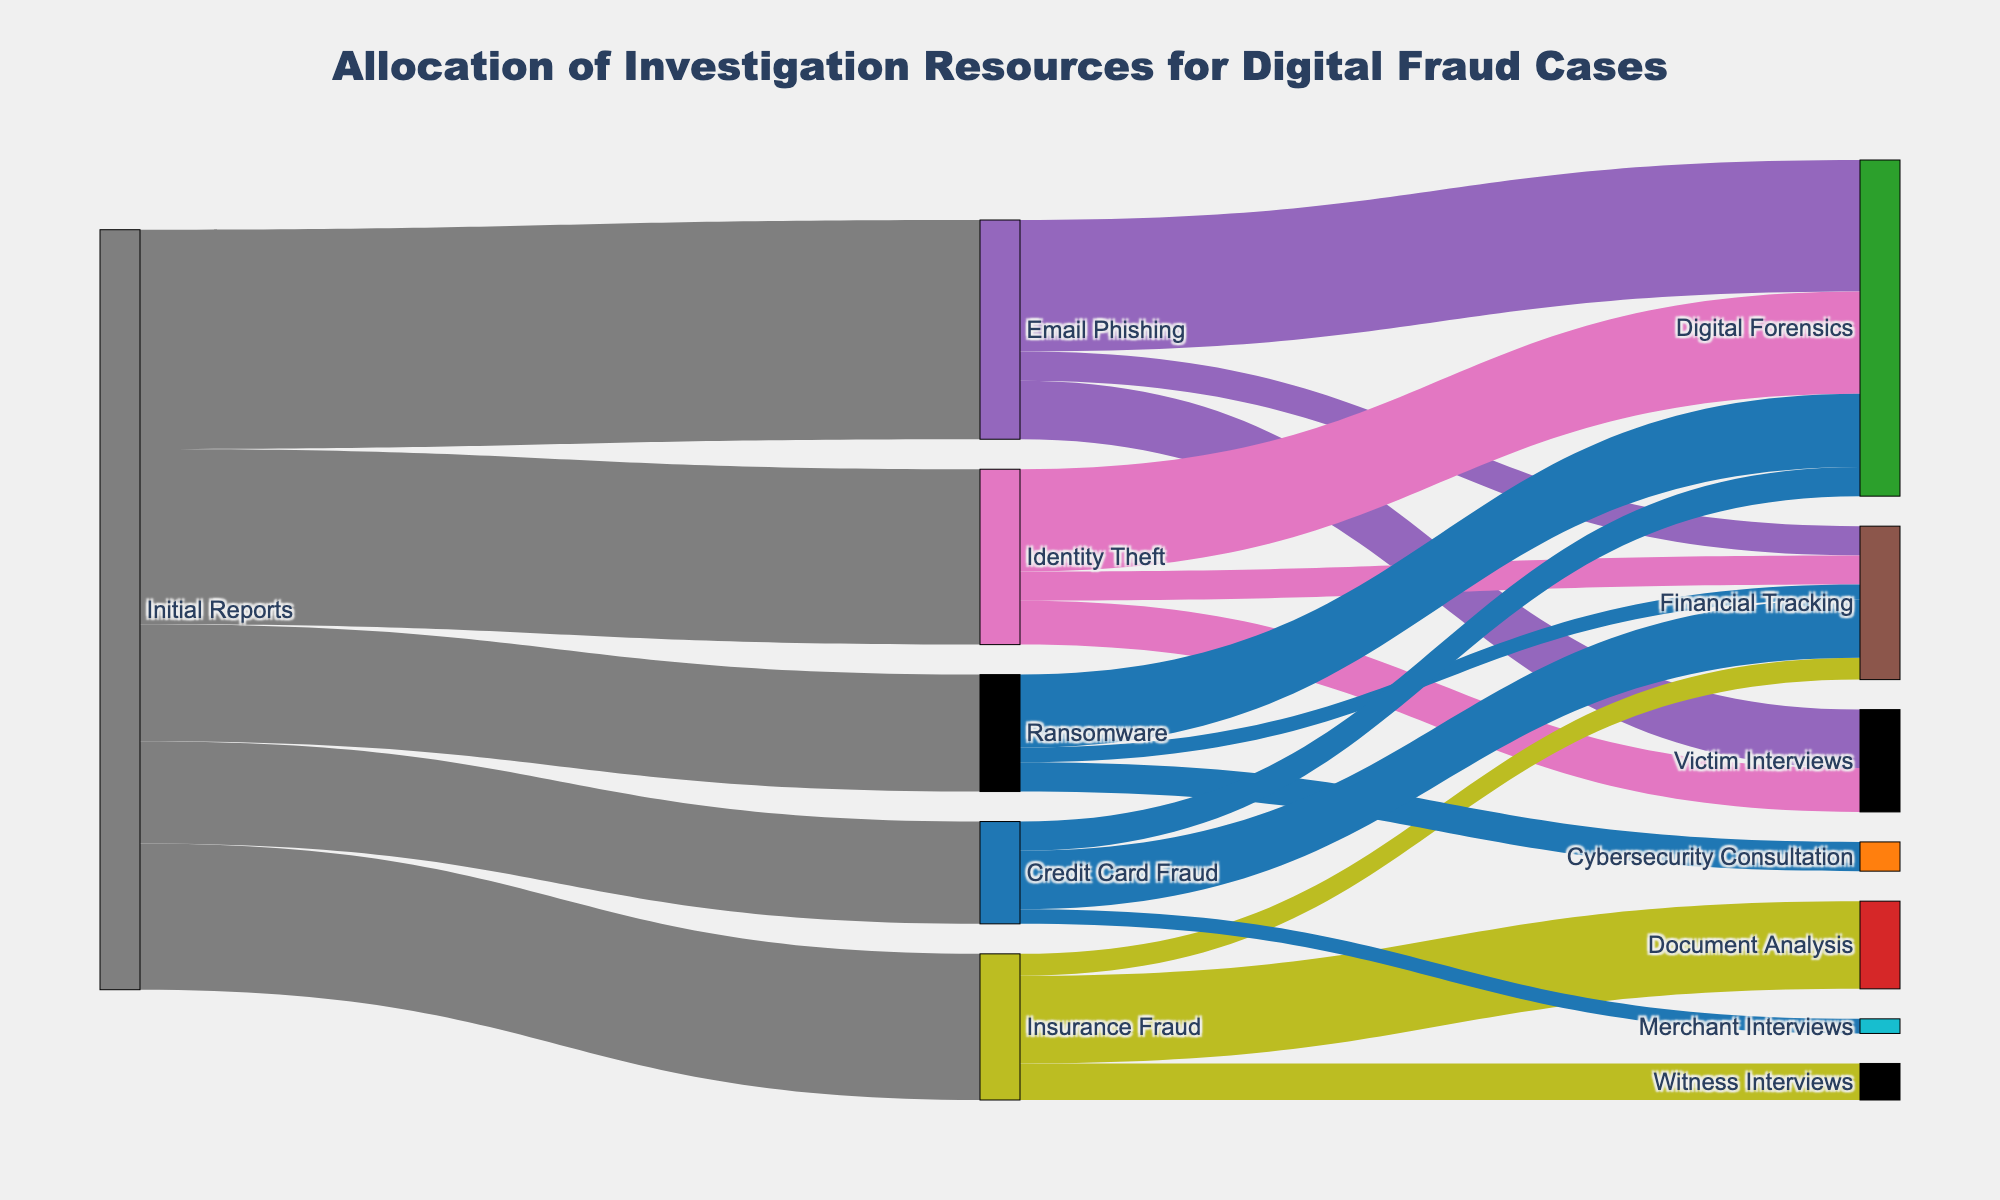What is the title of the Sankey diagram? The title is usually found at the top of the diagram. The title for this Sankey diagram is "Allocation of Investigation Resources for Digital Fraud Cases."
Answer: Allocation of Investigation Resources for Digital Fraud Cases How many different types of fraud cases are reported in the initial reports? To determine this, look at the sources under "Initial Reports." They are Email Phishing, Identity Theft, Insurance Fraud, Ransomware, and Credit Card Fraud. Counting these gives us five.
Answer: Five Which fraud type has the highest number of initial reports? Based on the diagram, check the values associated with each type of fraud stemming from "Initial Reports." The highest value is 150 for Email Phishing.
Answer: Email Phishing How many investigation resources are allocated to Digital Forensics from all fraud types combined? Add the values pointing to Digital Forensics from each fraud type: Email Phishing (90) + Identity Theft (70) + Ransomware (50) + Credit Card Fraud (20). The total is 90 + 70 + 50 + 20 = 230.
Answer: 230 How does the allocation of resources compare between Email Phishing and Insurance Fraud? Sum the resources for each fraud type:
Email Phishing: Digital Forensics (90) + Victim Interviews (40) + Financial Tracking (20) = 150
Insurance Fraud: Document Analysis (60) + Witness Interviews (25) + Financial Tracking (15) = 100
Email Phishing has more resources allocated (150 vs. 100).
Answer: Email Phishing has more resources allocated Which investigation resource is linked to the most types of fraud cases? Check which resource appears as a target for the most different fraud cases:
- Digital Forensics (4: Email Phishing, Identity Theft, Ransomware, Credit Card Fraud)
- Financial Tracking (4: Email Phishing, Identity Theft, Insurance Fraud, Ransomware)
Digital Forensics is linked to the most types of fraud cases.
Answer: Digital Forensics What is the total number of investigation resources allocated to Victim Interviews? Add the values pointing to Victim Interviews from each fraud type: Email Phishing (40) + Identity Theft (30). The total is 40 + 30 = 70.
Answer: 70 Which fraud type has the least amount of initial reports? Compare the initial report values for each fraud type: Email Phishing (150), Identity Theft (120), Insurance Fraud (100), Ransomware (80), Credit Card Fraud (70). Credit Card Fraud has the least amount of initial reports at 70.
Answer: Credit Card Fraud How many resources are allocated to Financial Tracking across all fraud cases? Add the values directed towards Financial Tracking from all sources: Email Phishing (20) + Identity Theft (20) + Insurance Fraud (15) + Ransomware (10) + Credit Card Fraud (40). The total is 20 + 20 + 15 + 10 + 40 = 105.
Answer: 105 What percentage of resources for Ransomware is allocated to Cybersecurity Consultation? Calculate the percentage of Cybersecurity Consultation relative to the total for Ransomware: (Cybersecurity Consultation (20) / Total for Ransomware (80)) * 100 = (20 / 80) * 100 = 25%.
Answer: 25% 